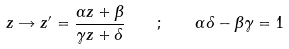Convert formula to latex. <formula><loc_0><loc_0><loc_500><loc_500>z \rightarrow z ^ { \prime } = \frac { \alpha z + \beta } { \gamma z + \delta } \quad ; \quad \alpha \delta - \beta \gamma = 1</formula> 